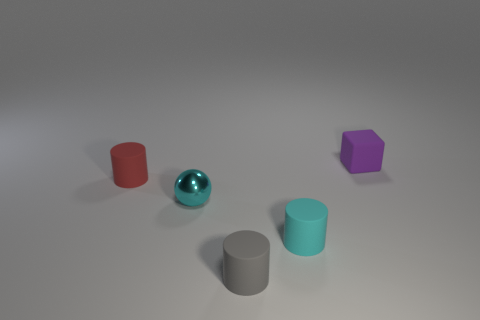What number of other blocks have the same color as the cube?
Your response must be concise. 0. Are there fewer tiny purple rubber blocks that are to the right of the small rubber block than tiny matte objects that are in front of the red rubber cylinder?
Provide a short and direct response. Yes. There is a cyan metal thing; are there any tiny things behind it?
Give a very brief answer. Yes. There is a object on the right side of the rubber cylinder that is on the right side of the tiny gray rubber object; are there any small matte cylinders in front of it?
Provide a succinct answer. Yes. Does the cyan object that is right of the metallic thing have the same shape as the gray matte object?
Provide a succinct answer. Yes. What color is the cube that is made of the same material as the red thing?
Your response must be concise. Purple. How many red cylinders are the same material as the tiny gray cylinder?
Keep it short and to the point. 1. There is a rubber thing that is behind the small cylinder that is behind the small cyan object behind the cyan rubber cylinder; what color is it?
Make the answer very short. Purple. Are there any other things that have the same shape as the cyan rubber object?
Offer a terse response. Yes. What number of things are either tiny matte cylinders that are to the right of the small cyan shiny ball or big red blocks?
Your response must be concise. 2. 